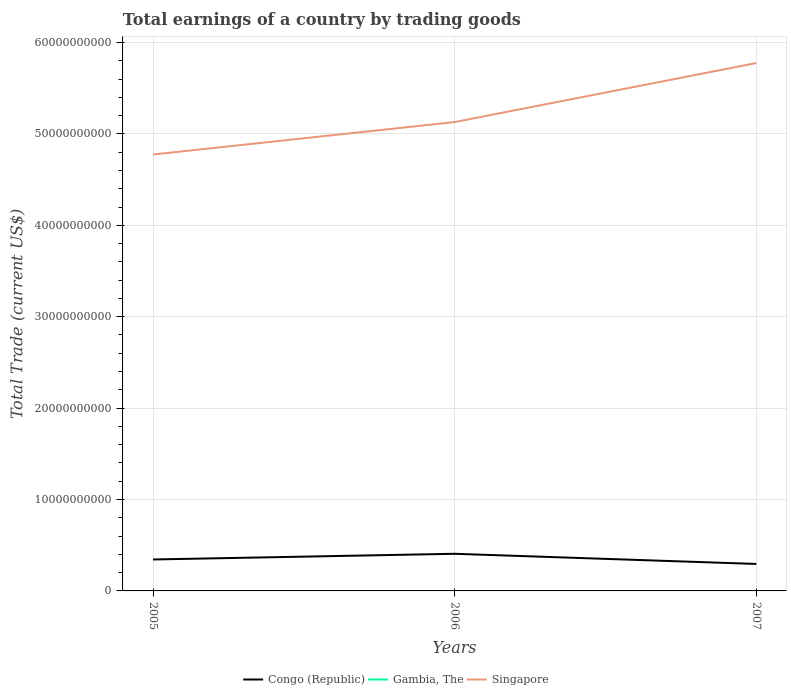Does the line corresponding to Congo (Republic) intersect with the line corresponding to Gambia, The?
Provide a succinct answer. No. Across all years, what is the maximum total earnings in Congo (Republic)?
Your answer should be very brief. 2.95e+09. What is the total total earnings in Singapore in the graph?
Your answer should be very brief. -3.55e+09. What is the difference between the highest and the second highest total earnings in Singapore?
Your response must be concise. 1.00e+1. What is the difference between the highest and the lowest total earnings in Gambia, The?
Your answer should be very brief. 0. Are the values on the major ticks of Y-axis written in scientific E-notation?
Your answer should be very brief. No. How many legend labels are there?
Make the answer very short. 3. What is the title of the graph?
Make the answer very short. Total earnings of a country by trading goods. What is the label or title of the Y-axis?
Offer a very short reply. Total Trade (current US$). What is the Total Trade (current US$) of Congo (Republic) in 2005?
Ensure brevity in your answer.  3.44e+09. What is the Total Trade (current US$) of Singapore in 2005?
Ensure brevity in your answer.  4.77e+1. What is the Total Trade (current US$) in Congo (Republic) in 2006?
Offer a terse response. 4.06e+09. What is the Total Trade (current US$) of Singapore in 2006?
Provide a succinct answer. 5.13e+1. What is the Total Trade (current US$) of Congo (Republic) in 2007?
Provide a succinct answer. 2.95e+09. What is the Total Trade (current US$) in Singapore in 2007?
Your answer should be compact. 5.77e+1. Across all years, what is the maximum Total Trade (current US$) in Congo (Republic)?
Your answer should be compact. 4.06e+09. Across all years, what is the maximum Total Trade (current US$) of Singapore?
Keep it short and to the point. 5.77e+1. Across all years, what is the minimum Total Trade (current US$) in Congo (Republic)?
Your answer should be very brief. 2.95e+09. Across all years, what is the minimum Total Trade (current US$) in Singapore?
Offer a very short reply. 4.77e+1. What is the total Total Trade (current US$) in Congo (Republic) in the graph?
Offer a terse response. 1.05e+1. What is the total Total Trade (current US$) in Gambia, The in the graph?
Ensure brevity in your answer.  0. What is the total Total Trade (current US$) in Singapore in the graph?
Provide a short and direct response. 1.57e+11. What is the difference between the Total Trade (current US$) of Congo (Republic) in 2005 and that in 2006?
Make the answer very short. -6.22e+08. What is the difference between the Total Trade (current US$) of Singapore in 2005 and that in 2006?
Provide a succinct answer. -3.55e+09. What is the difference between the Total Trade (current US$) of Congo (Republic) in 2005 and that in 2007?
Offer a terse response. 4.90e+08. What is the difference between the Total Trade (current US$) in Singapore in 2005 and that in 2007?
Make the answer very short. -1.00e+1. What is the difference between the Total Trade (current US$) in Congo (Republic) in 2006 and that in 2007?
Keep it short and to the point. 1.11e+09. What is the difference between the Total Trade (current US$) of Singapore in 2006 and that in 2007?
Provide a short and direct response. -6.46e+09. What is the difference between the Total Trade (current US$) in Congo (Republic) in 2005 and the Total Trade (current US$) in Singapore in 2006?
Provide a succinct answer. -4.79e+1. What is the difference between the Total Trade (current US$) in Congo (Republic) in 2005 and the Total Trade (current US$) in Singapore in 2007?
Your answer should be compact. -5.43e+1. What is the difference between the Total Trade (current US$) in Congo (Republic) in 2006 and the Total Trade (current US$) in Singapore in 2007?
Give a very brief answer. -5.37e+1. What is the average Total Trade (current US$) in Congo (Republic) per year?
Offer a very short reply. 3.48e+09. What is the average Total Trade (current US$) in Gambia, The per year?
Your response must be concise. 0. What is the average Total Trade (current US$) in Singapore per year?
Give a very brief answer. 5.23e+1. In the year 2005, what is the difference between the Total Trade (current US$) in Congo (Republic) and Total Trade (current US$) in Singapore?
Keep it short and to the point. -4.43e+1. In the year 2006, what is the difference between the Total Trade (current US$) of Congo (Republic) and Total Trade (current US$) of Singapore?
Your answer should be very brief. -4.72e+1. In the year 2007, what is the difference between the Total Trade (current US$) in Congo (Republic) and Total Trade (current US$) in Singapore?
Ensure brevity in your answer.  -5.48e+1. What is the ratio of the Total Trade (current US$) of Congo (Republic) in 2005 to that in 2006?
Your answer should be compact. 0.85. What is the ratio of the Total Trade (current US$) in Singapore in 2005 to that in 2006?
Your response must be concise. 0.93. What is the ratio of the Total Trade (current US$) of Congo (Republic) in 2005 to that in 2007?
Offer a very short reply. 1.17. What is the ratio of the Total Trade (current US$) of Singapore in 2005 to that in 2007?
Provide a short and direct response. 0.83. What is the ratio of the Total Trade (current US$) of Congo (Republic) in 2006 to that in 2007?
Offer a terse response. 1.38. What is the ratio of the Total Trade (current US$) in Singapore in 2006 to that in 2007?
Make the answer very short. 0.89. What is the difference between the highest and the second highest Total Trade (current US$) in Congo (Republic)?
Your answer should be compact. 6.22e+08. What is the difference between the highest and the second highest Total Trade (current US$) of Singapore?
Provide a short and direct response. 6.46e+09. What is the difference between the highest and the lowest Total Trade (current US$) of Congo (Republic)?
Offer a very short reply. 1.11e+09. What is the difference between the highest and the lowest Total Trade (current US$) in Singapore?
Make the answer very short. 1.00e+1. 